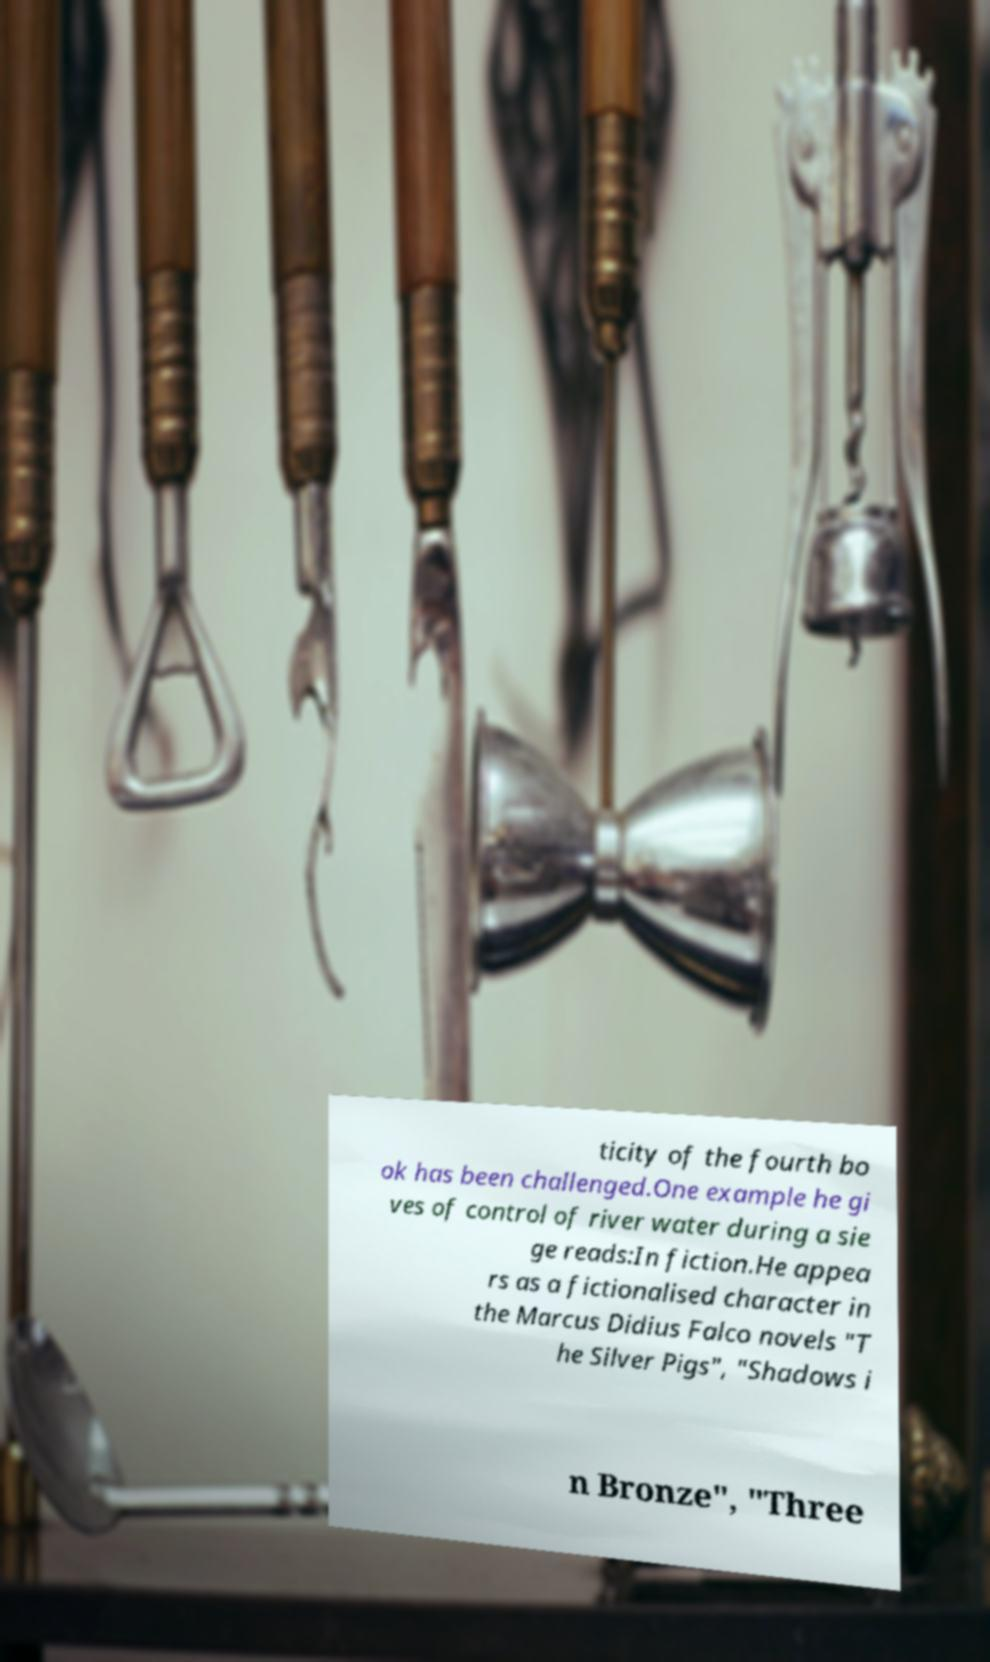I need the written content from this picture converted into text. Can you do that? ticity of the fourth bo ok has been challenged.One example he gi ves of control of river water during a sie ge reads:In fiction.He appea rs as a fictionalised character in the Marcus Didius Falco novels "T he Silver Pigs", "Shadows i n Bronze", "Three 